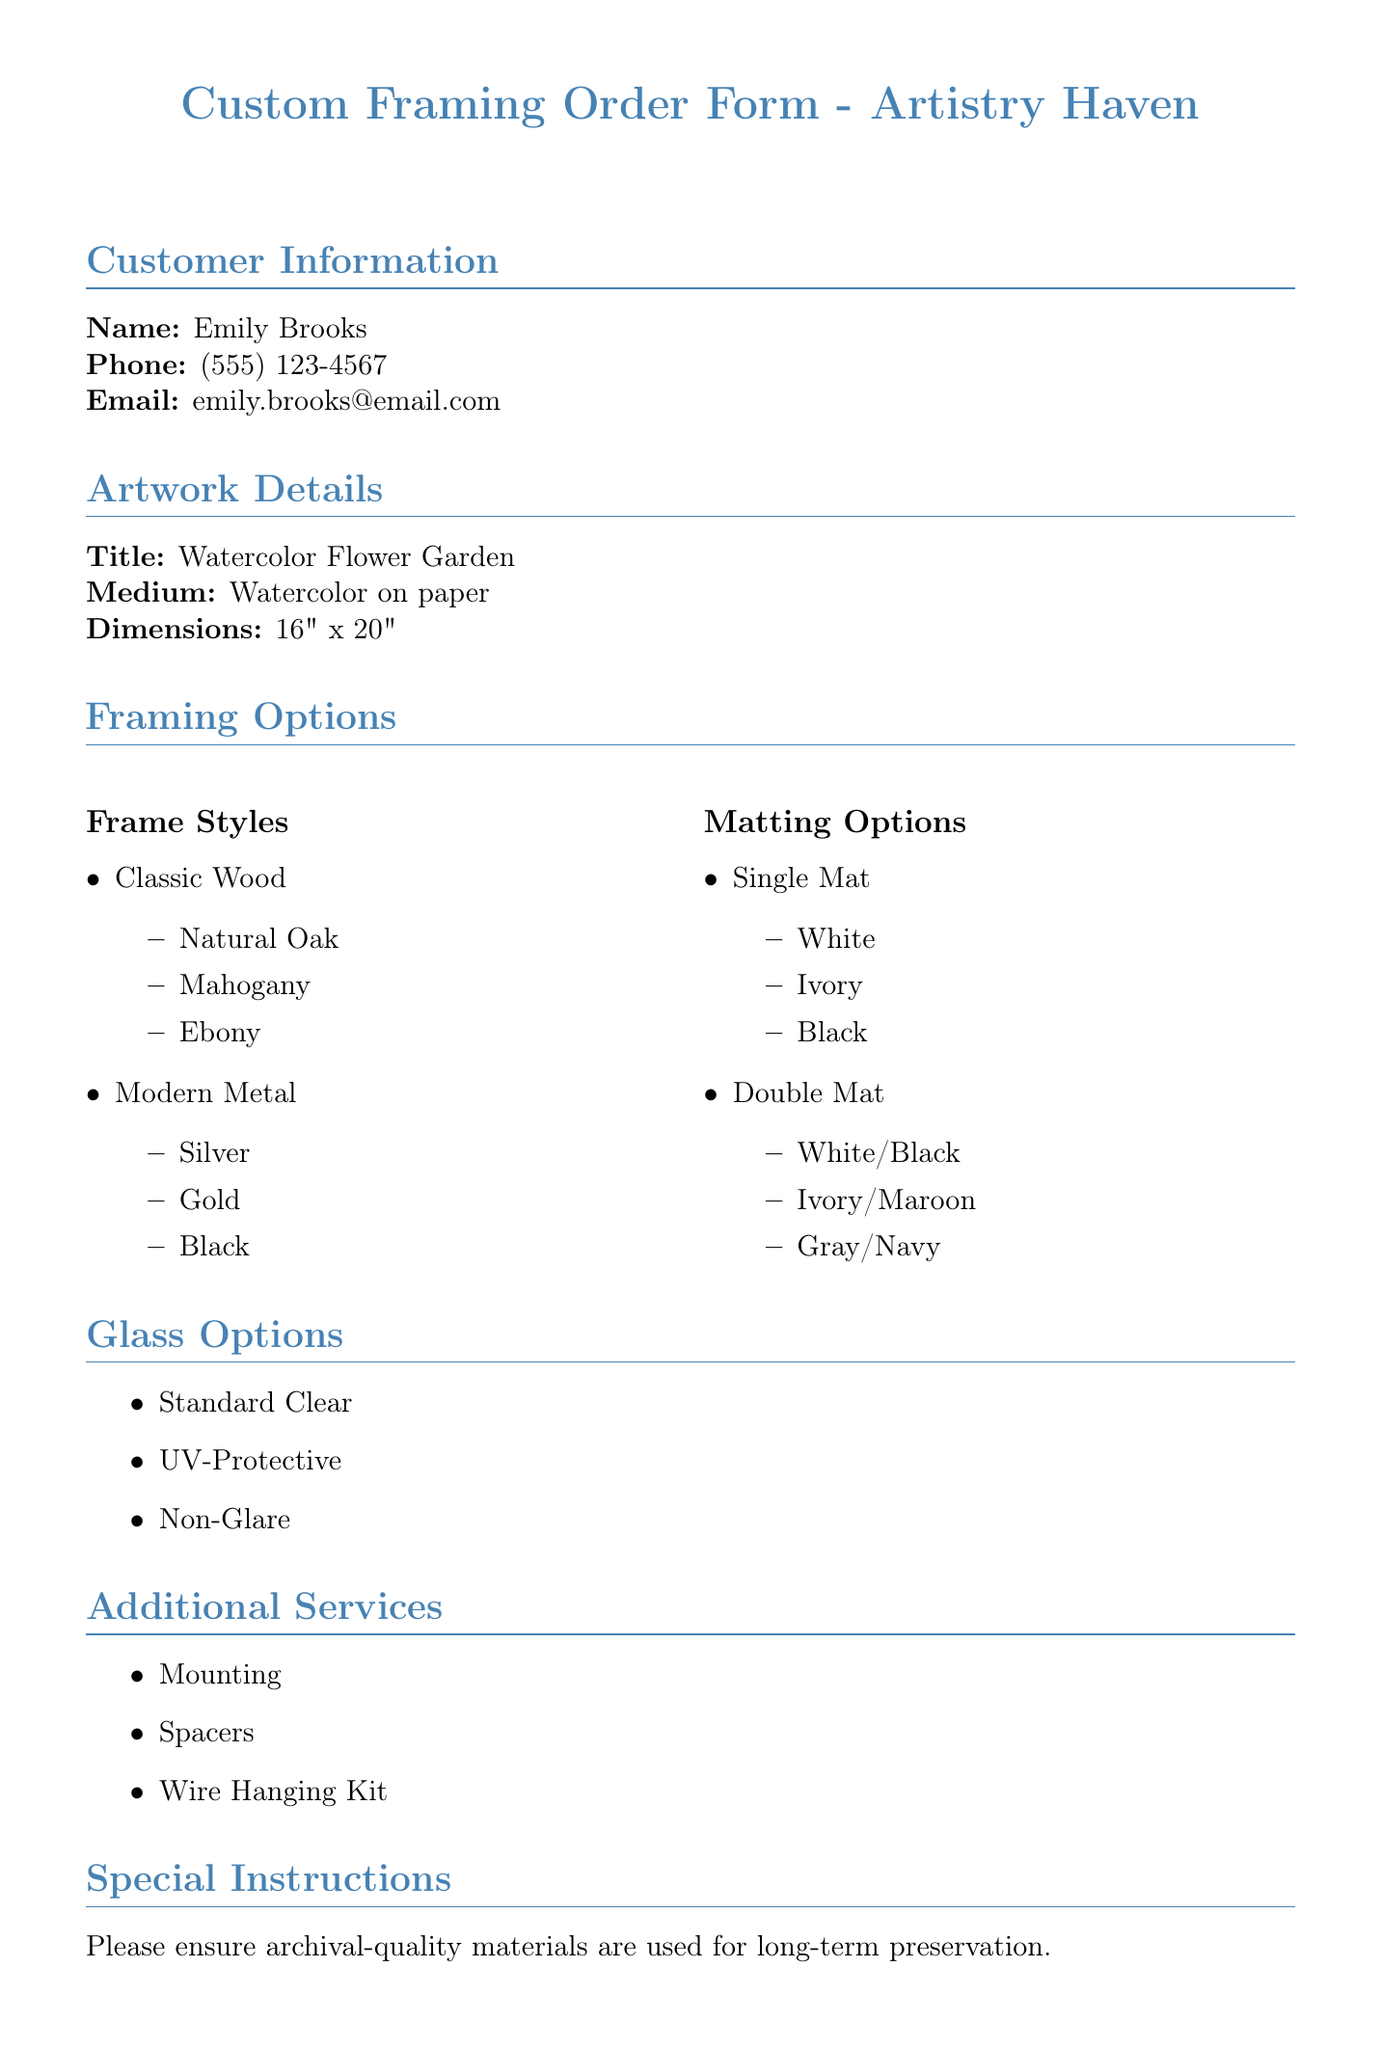What is the customer’s name? The name of the customer is clearly listed in the document under Customer Information.
Answer: Emily Brooks What is the size of the artwork? The artwork size is specified in the Artwork Details section of the document.
Answer: 16" x 20" What types of frame styles are available? The available frame styles are listed under Framing Options in the document.
Answer: Classic Wood, Modern Metal What are the options for single matting? The document provides specific matting options for single mats listed in the Matting Options section.
Answer: White, Ivory, Black How many glass options are there? The number of options is determined by counting the list items under the Glass Options section.
Answer: 3 What is the address of Artistry Haven? The document provides the address at the bottom of the page in the contact information.
Answer: 123 Creative Lane, Artville, ST 12345 Is there a discount for local art workshop participants? The document mentions a discount specifically for a certain group of people.
Answer: 10% What is the medium of the artwork? The medium is detailed in the Artwork Details section of the document.
Answer: Watercolor on paper What special instruction is provided? The document includes a note under Special Instructions regarding materials.
Answer: Archival-quality materials 